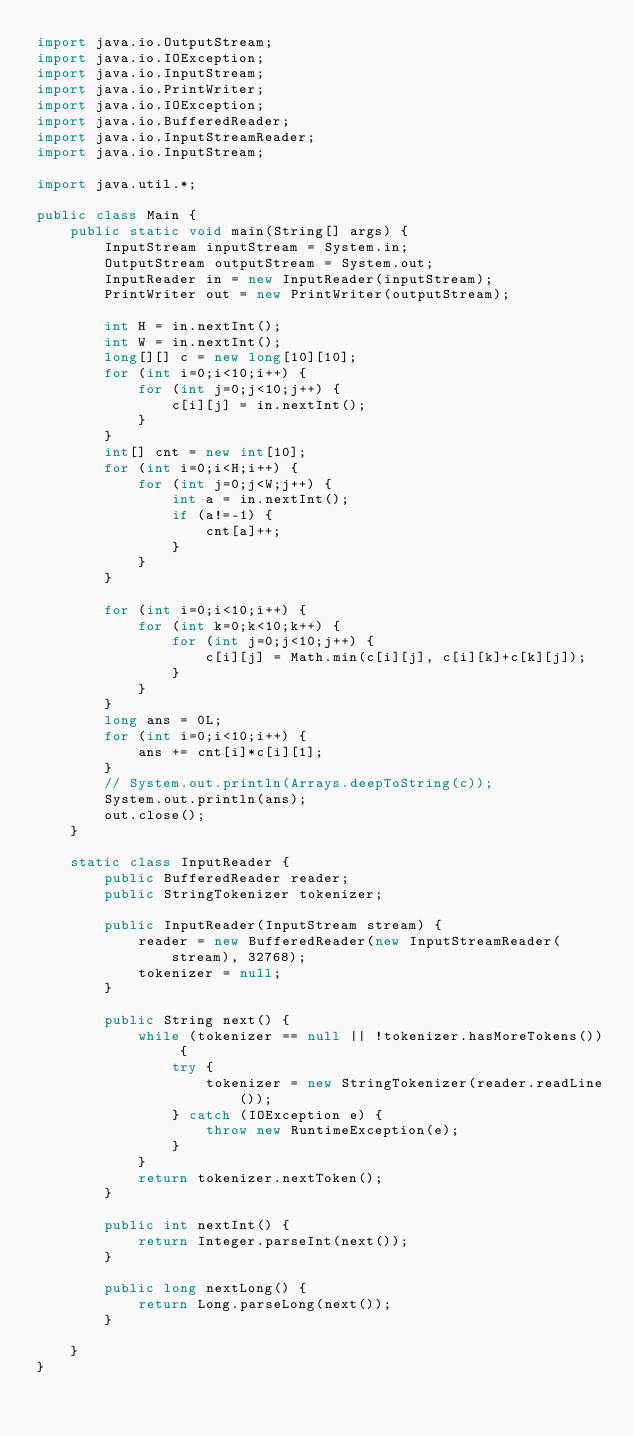Convert code to text. <code><loc_0><loc_0><loc_500><loc_500><_Java_>import java.io.OutputStream;
import java.io.IOException;
import java.io.InputStream;
import java.io.PrintWriter;
import java.io.IOException;
import java.io.BufferedReader;
import java.io.InputStreamReader;
import java.io.InputStream;

import java.util.*;

public class Main {
    public static void main(String[] args) {
        InputStream inputStream = System.in;
        OutputStream outputStream = System.out;
        InputReader in = new InputReader(inputStream);
        PrintWriter out = new PrintWriter(outputStream);

        int H = in.nextInt();
        int W = in.nextInt();
        long[][] c = new long[10][10];
        for (int i=0;i<10;i++) {
            for (int j=0;j<10;j++) {
                c[i][j] = in.nextInt();
            }
        }
        int[] cnt = new int[10];
        for (int i=0;i<H;i++) {
            for (int j=0;j<W;j++) {
                int a = in.nextInt();
                if (a!=-1) {
                    cnt[a]++;
                }
            }
        }

        for (int i=0;i<10;i++) {
            for (int k=0;k<10;k++) {
                for (int j=0;j<10;j++) {
                    c[i][j] = Math.min(c[i][j], c[i][k]+c[k][j]);
                }
            }
        }
        long ans = 0L;
        for (int i=0;i<10;i++) {
            ans += cnt[i]*c[i][1];
        }
        // System.out.println(Arrays.deepToString(c));
        System.out.println(ans);
        out.close();
    }

    static class InputReader {
        public BufferedReader reader;
        public StringTokenizer tokenizer;

        public InputReader(InputStream stream) {
            reader = new BufferedReader(new InputStreamReader(stream), 32768);
            tokenizer = null;
        }

        public String next() {
            while (tokenizer == null || !tokenizer.hasMoreTokens()) {
                try {
                    tokenizer = new StringTokenizer(reader.readLine());
                } catch (IOException e) {
                    throw new RuntimeException(e);
                }
            }
            return tokenizer.nextToken();
        }

        public int nextInt() {
            return Integer.parseInt(next());
        }

        public long nextLong() {
            return Long.parseLong(next());
        }

    }
}
</code> 